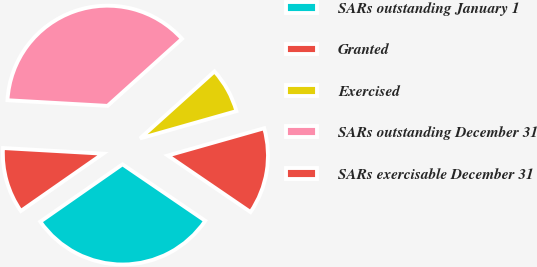<chart> <loc_0><loc_0><loc_500><loc_500><pie_chart><fcel>SARs outstanding January 1<fcel>Granted<fcel>Exercised<fcel>SARs outstanding December 31<fcel>SARs exercisable December 31<nl><fcel>30.77%<fcel>13.93%<fcel>7.27%<fcel>37.43%<fcel>10.59%<nl></chart> 